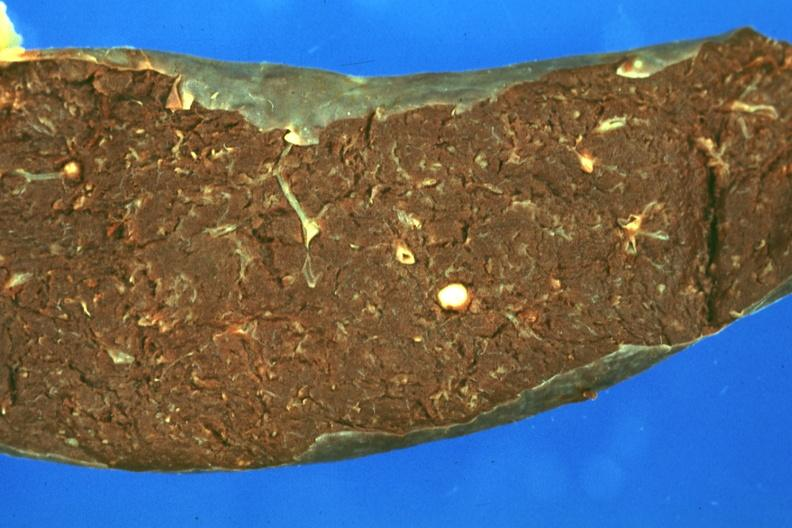what is present?
Answer the question using a single word or phrase. Hematologic 